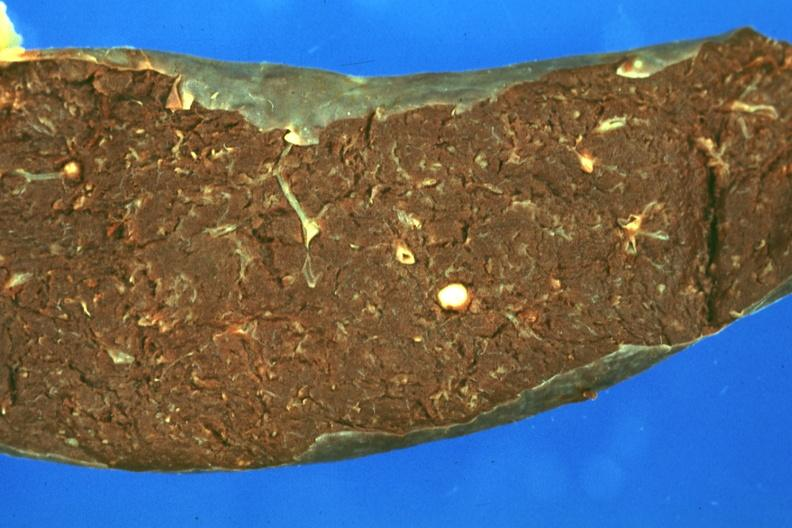what is present?
Answer the question using a single word or phrase. Hematologic 